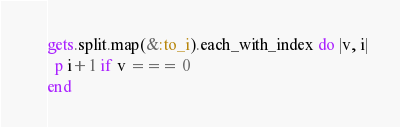Convert code to text. <code><loc_0><loc_0><loc_500><loc_500><_Ruby_>gets.split.map(&:to_i).each_with_index do |v, i|
  p i+1 if v === 0
end</code> 